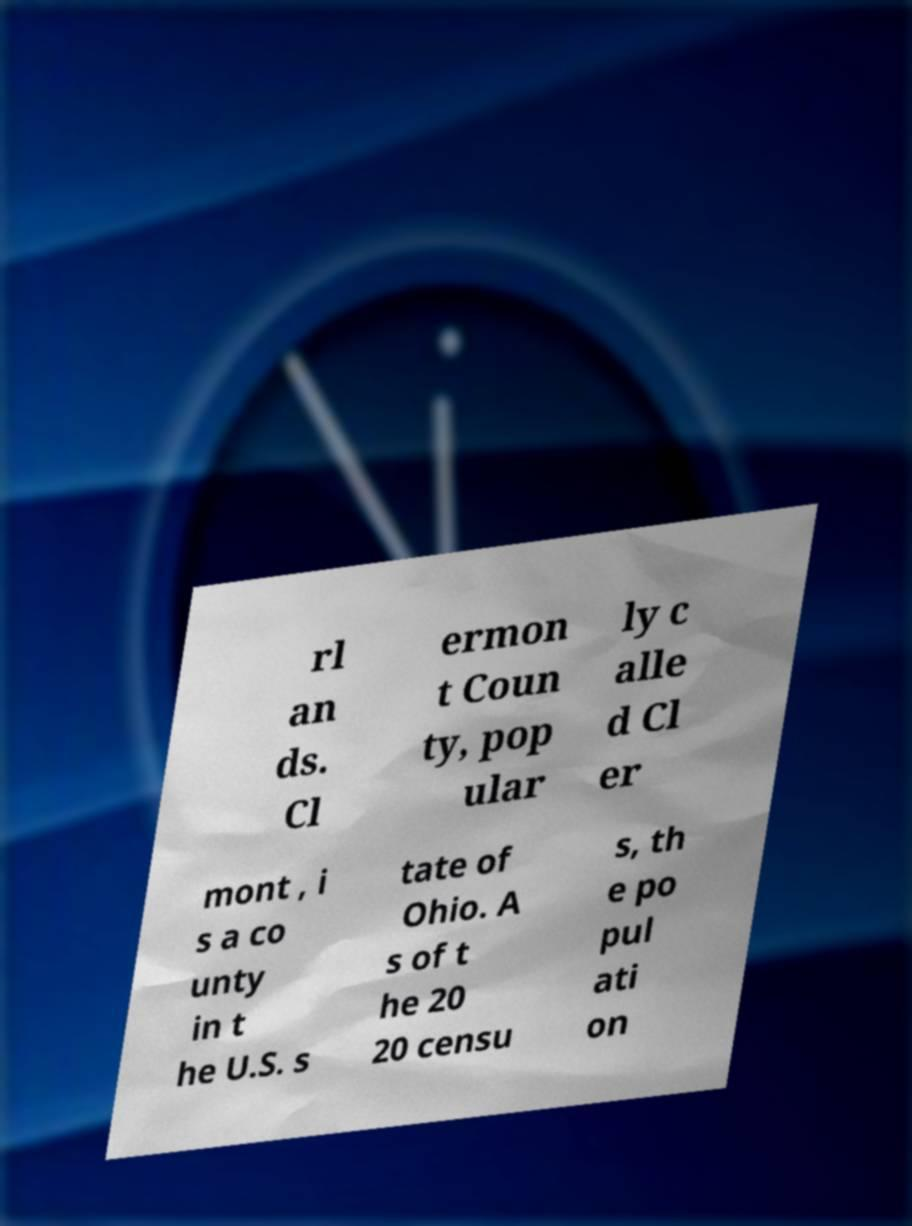Could you extract and type out the text from this image? rl an ds. Cl ermon t Coun ty, pop ular ly c alle d Cl er mont , i s a co unty in t he U.S. s tate of Ohio. A s of t he 20 20 censu s, th e po pul ati on 